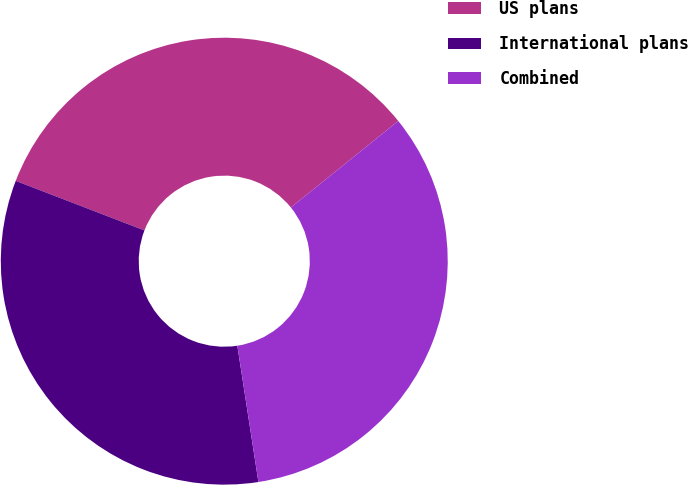<chart> <loc_0><loc_0><loc_500><loc_500><pie_chart><fcel>US plans<fcel>International plans<fcel>Combined<nl><fcel>33.35%<fcel>33.29%<fcel>33.35%<nl></chart> 